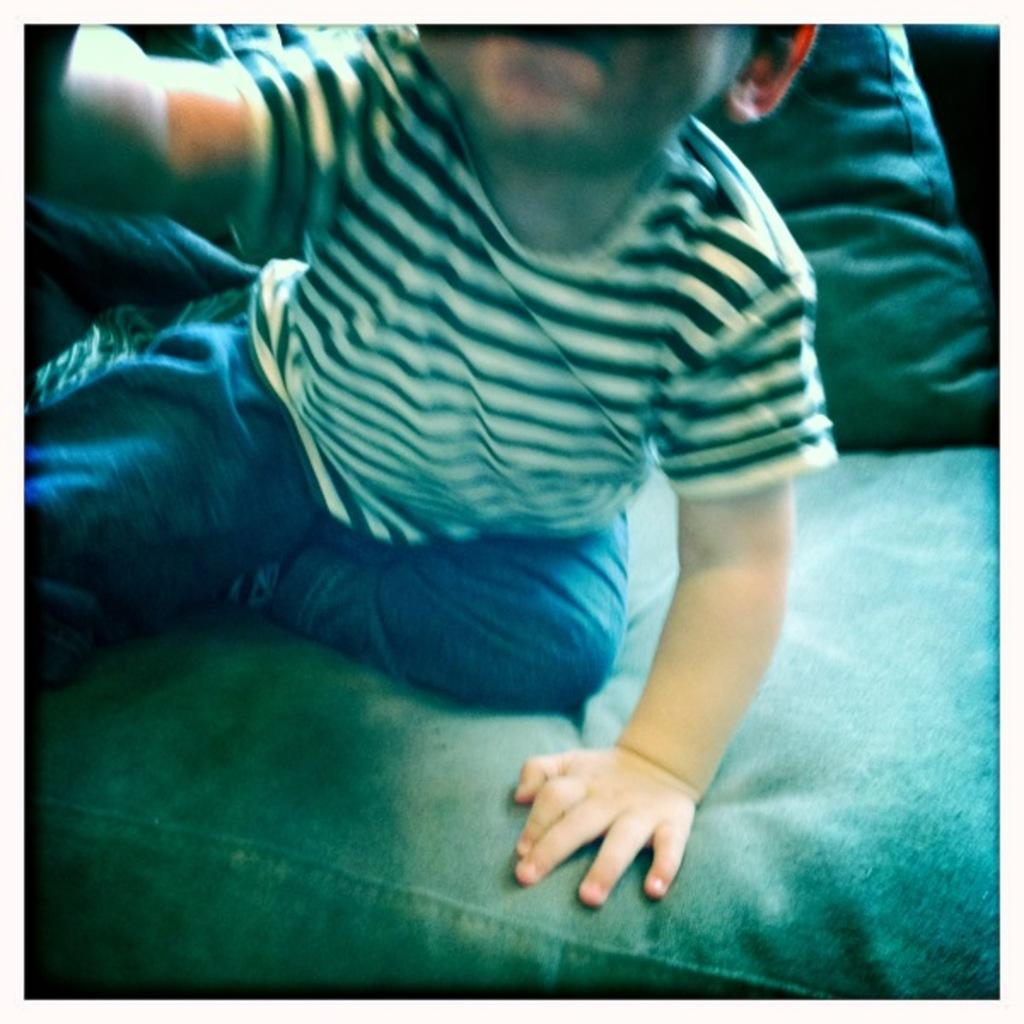What is the main subject of the image? The main subject of the image is a child. Where is the child located in the image? The child is sitting on a sofa. What other object can be seen in the image? There is a cushion in the image. What type of bat is the child playing with in the image? There is no bat present in the image; the child is sitting on a sofa. What medical condition is the doctor treating the child for in the image? There is no doctor or medical condition present in the image; it only features a child sitting on a sofa. 